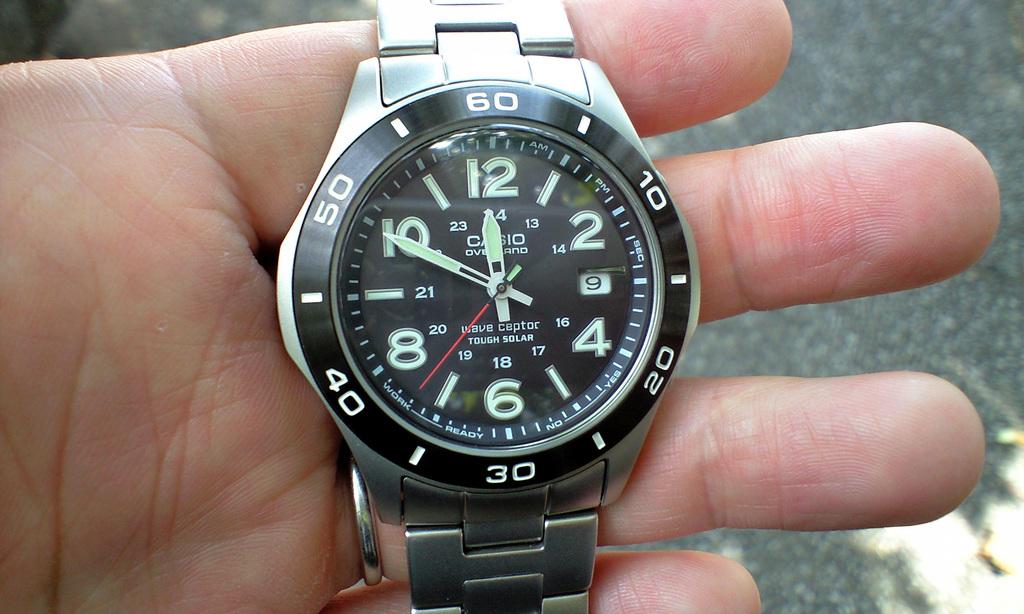What is the time shown?
Ensure brevity in your answer.  11:50. What time does the watch say it is?
Your answer should be compact. 11:50. 